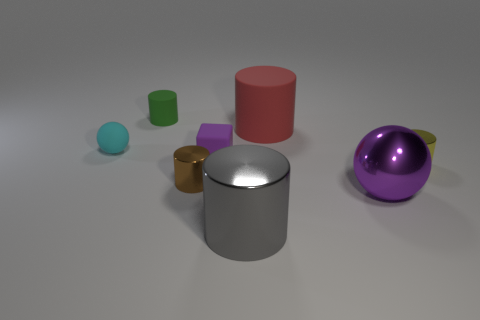Add 1 big purple spheres. How many objects exist? 9 Subtract all small yellow cylinders. How many cylinders are left? 4 Subtract all cyan balls. How many balls are left? 1 Subtract 1 balls. How many balls are left? 1 Subtract all cubes. How many objects are left? 7 Subtract all large yellow metallic balls. Subtract all cyan spheres. How many objects are left? 7 Add 7 large gray shiny cylinders. How many large gray shiny cylinders are left? 8 Add 8 big gray objects. How many big gray objects exist? 9 Subtract 0 brown cubes. How many objects are left? 8 Subtract all purple cylinders. Subtract all blue blocks. How many cylinders are left? 5 